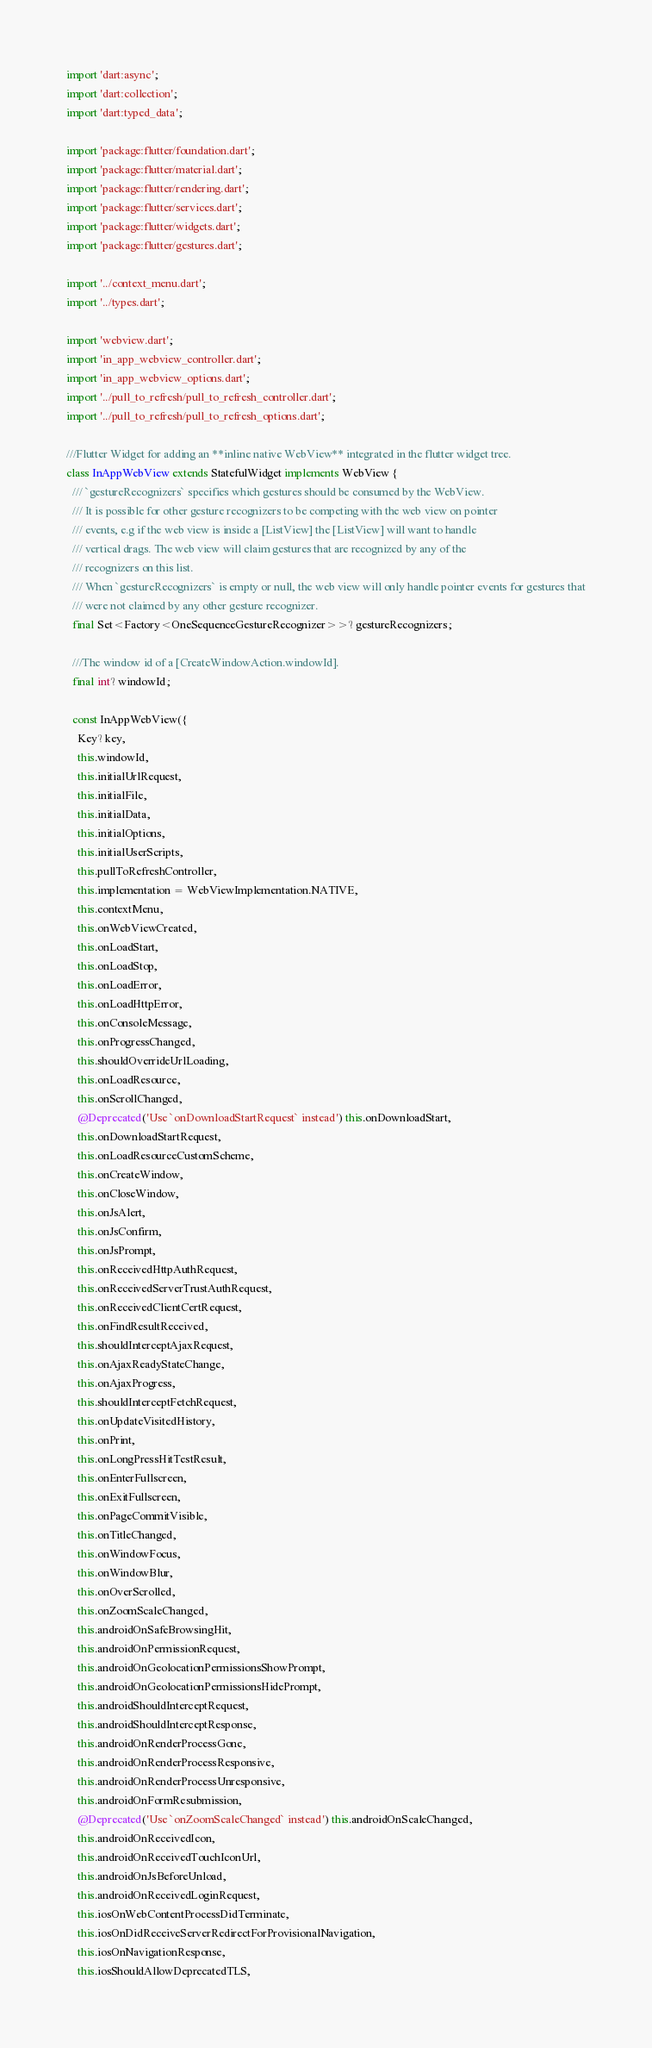<code> <loc_0><loc_0><loc_500><loc_500><_Dart_>import 'dart:async';
import 'dart:collection';
import 'dart:typed_data';

import 'package:flutter/foundation.dart';
import 'package:flutter/material.dart';
import 'package:flutter/rendering.dart';
import 'package:flutter/services.dart';
import 'package:flutter/widgets.dart';
import 'package:flutter/gestures.dart';

import '../context_menu.dart';
import '../types.dart';

import 'webview.dart';
import 'in_app_webview_controller.dart';
import 'in_app_webview_options.dart';
import '../pull_to_refresh/pull_to_refresh_controller.dart';
import '../pull_to_refresh/pull_to_refresh_options.dart';

///Flutter Widget for adding an **inline native WebView** integrated in the flutter widget tree.
class InAppWebView extends StatefulWidget implements WebView {
  /// `gestureRecognizers` specifies which gestures should be consumed by the WebView.
  /// It is possible for other gesture recognizers to be competing with the web view on pointer
  /// events, e.g if the web view is inside a [ListView] the [ListView] will want to handle
  /// vertical drags. The web view will claim gestures that are recognized by any of the
  /// recognizers on this list.
  /// When `gestureRecognizers` is empty or null, the web view will only handle pointer events for gestures that
  /// were not claimed by any other gesture recognizer.
  final Set<Factory<OneSequenceGestureRecognizer>>? gestureRecognizers;

  ///The window id of a [CreateWindowAction.windowId].
  final int? windowId;

  const InAppWebView({
    Key? key,
    this.windowId,
    this.initialUrlRequest,
    this.initialFile,
    this.initialData,
    this.initialOptions,
    this.initialUserScripts,
    this.pullToRefreshController,
    this.implementation = WebViewImplementation.NATIVE,
    this.contextMenu,
    this.onWebViewCreated,
    this.onLoadStart,
    this.onLoadStop,
    this.onLoadError,
    this.onLoadHttpError,
    this.onConsoleMessage,
    this.onProgressChanged,
    this.shouldOverrideUrlLoading,
    this.onLoadResource,
    this.onScrollChanged,
    @Deprecated('Use `onDownloadStartRequest` instead') this.onDownloadStart,
    this.onDownloadStartRequest,
    this.onLoadResourceCustomScheme,
    this.onCreateWindow,
    this.onCloseWindow,
    this.onJsAlert,
    this.onJsConfirm,
    this.onJsPrompt,
    this.onReceivedHttpAuthRequest,
    this.onReceivedServerTrustAuthRequest,
    this.onReceivedClientCertRequest,
    this.onFindResultReceived,
    this.shouldInterceptAjaxRequest,
    this.onAjaxReadyStateChange,
    this.onAjaxProgress,
    this.shouldInterceptFetchRequest,
    this.onUpdateVisitedHistory,
    this.onPrint,
    this.onLongPressHitTestResult,
    this.onEnterFullscreen,
    this.onExitFullscreen,
    this.onPageCommitVisible,
    this.onTitleChanged,
    this.onWindowFocus,
    this.onWindowBlur,
    this.onOverScrolled,
    this.onZoomScaleChanged,
    this.androidOnSafeBrowsingHit,
    this.androidOnPermissionRequest,
    this.androidOnGeolocationPermissionsShowPrompt,
    this.androidOnGeolocationPermissionsHidePrompt,
    this.androidShouldInterceptRequest,
    this.androidShouldInterceptResponse,
    this.androidOnRenderProcessGone,
    this.androidOnRenderProcessResponsive,
    this.androidOnRenderProcessUnresponsive,
    this.androidOnFormResubmission,
    @Deprecated('Use `onZoomScaleChanged` instead') this.androidOnScaleChanged,
    this.androidOnReceivedIcon,
    this.androidOnReceivedTouchIconUrl,
    this.androidOnJsBeforeUnload,
    this.androidOnReceivedLoginRequest,
    this.iosOnWebContentProcessDidTerminate,
    this.iosOnDidReceiveServerRedirectForProvisionalNavigation,
    this.iosOnNavigationResponse,
    this.iosShouldAllowDeprecatedTLS,</code> 